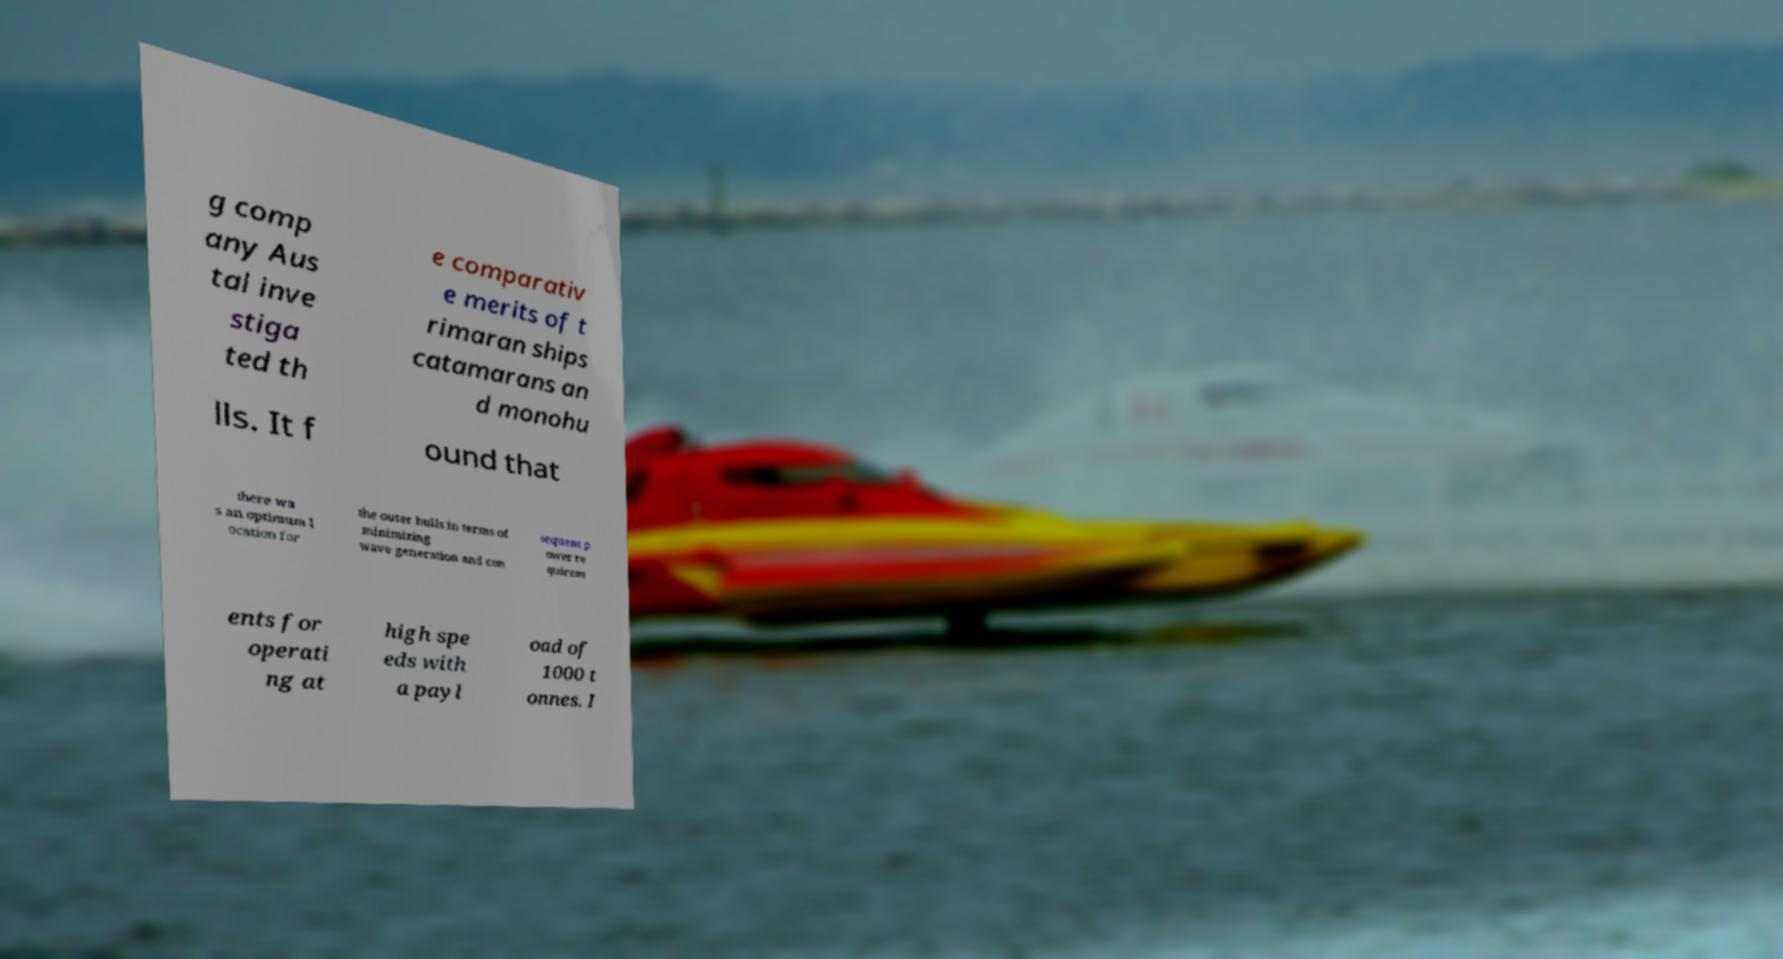Could you extract and type out the text from this image? g comp any Aus tal inve stiga ted th e comparativ e merits of t rimaran ships catamarans an d monohu lls. It f ound that there wa s an optimum l ocation for the outer hulls in terms of minimizing wave generation and con sequent p ower re quirem ents for operati ng at high spe eds with a payl oad of 1000 t onnes. I 